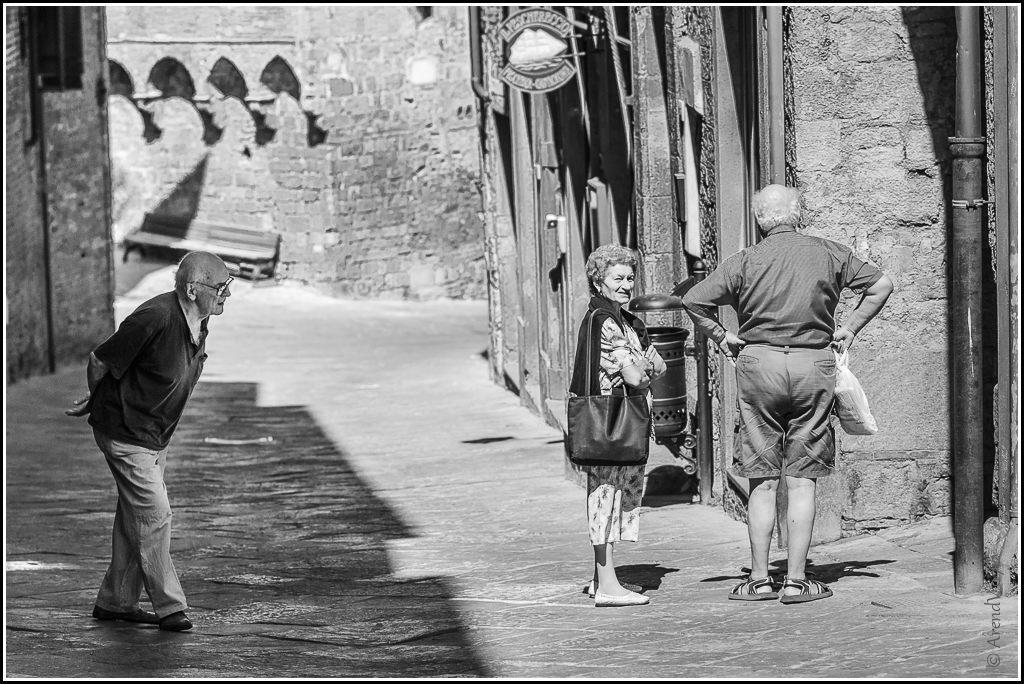What is the color scheme of the image? The image is black and white. What are the people in the image doing? The people are standing on the ground in the image. What is the man holding in the image? The man is holding a bag in the image. What type of structures can be seen in the image? There are poles and walls visible in the image. What is the purpose of the sign board in the image? The sign board in the image is likely used for providing information or directions. What type of seating is present in the image? There is a bench in the image. Can you see a ship sailing in the background of the image? No, there is no ship visible in the image. What type of branch is the man holding in the image? There is no branch present in the image; the man is holding a bag. 